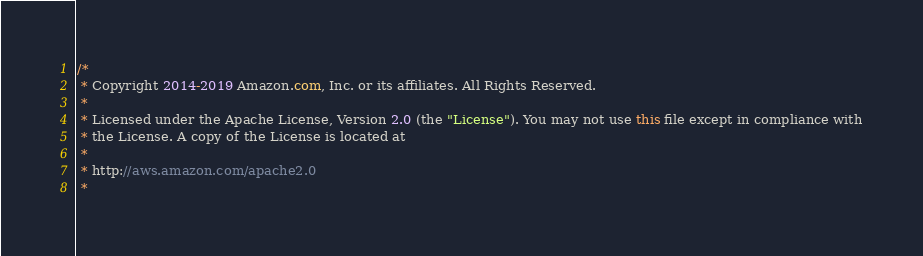<code> <loc_0><loc_0><loc_500><loc_500><_Java_>/*
 * Copyright 2014-2019 Amazon.com, Inc. or its affiliates. All Rights Reserved.
 * 
 * Licensed under the Apache License, Version 2.0 (the "License"). You may not use this file except in compliance with
 * the License. A copy of the License is located at
 * 
 * http://aws.amazon.com/apache2.0
 * </code> 